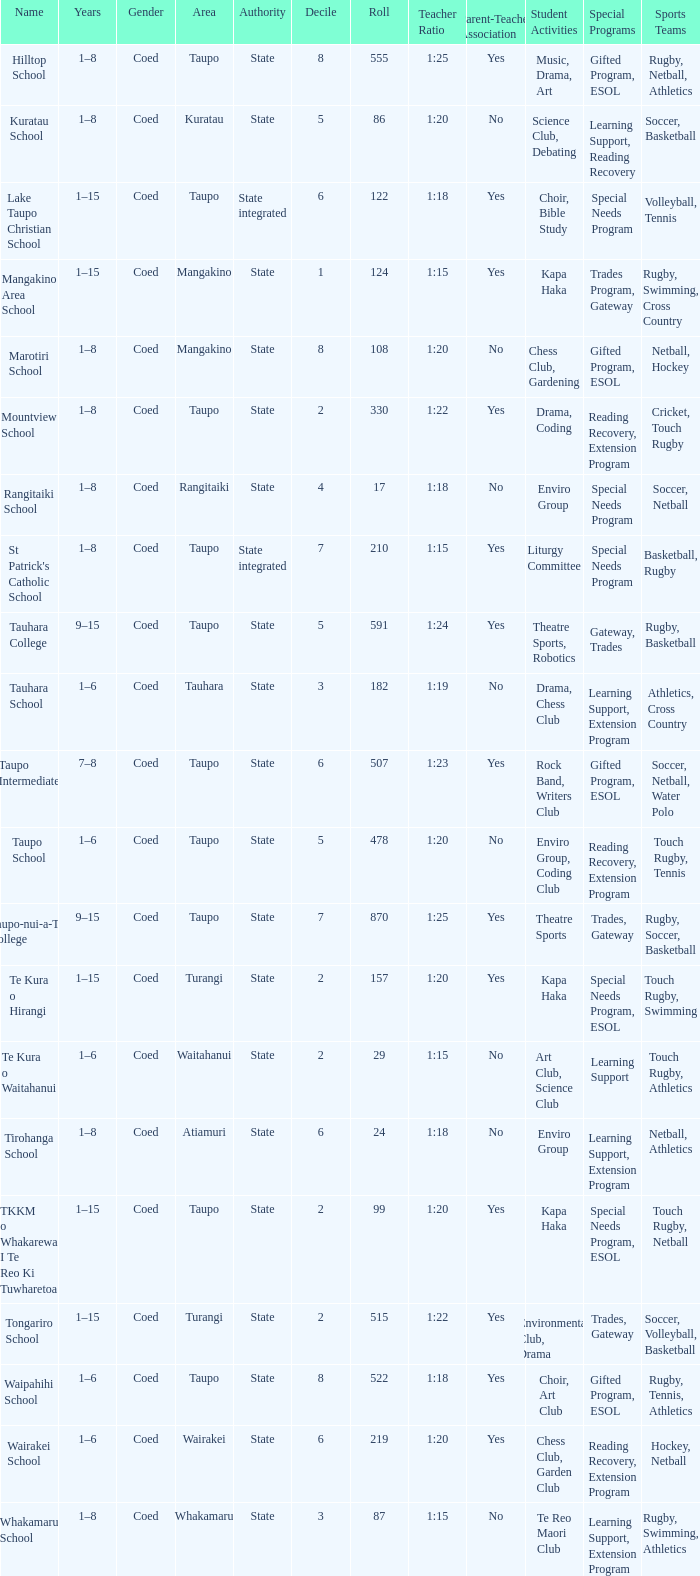Where is the school with state authority that has a roll of more than 157 students? Taupo, Taupo, Taupo, Tauhara, Taupo, Taupo, Taupo, Turangi, Taupo, Wairakei. 